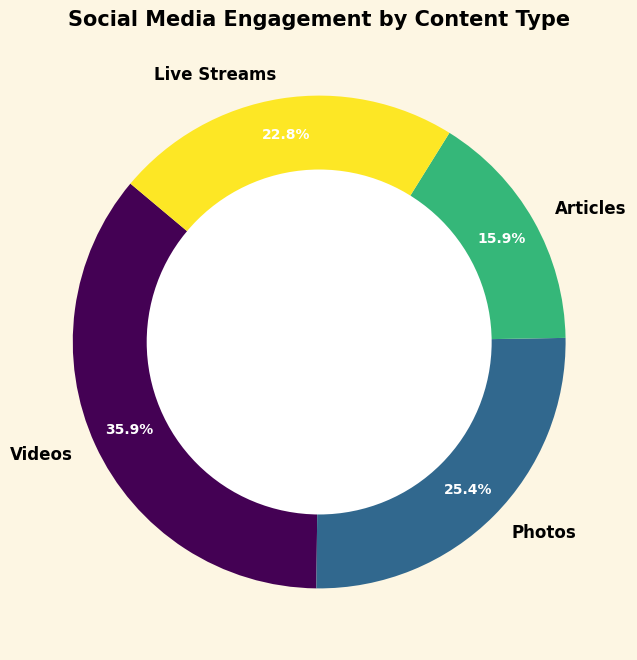What percentage of engagement comes from Videos? By looking at the figure, find the slice labeled "Videos" and locate its percentage label.
Answer: 37.5% Which content type has the least engagement? By observing the sizes of the slices in the ring chart, find the smallest one, which will have the lowest engagement.
Answer: Articles How much more engagement do Videos have compared to Live Streams? From the chart, find the engagement values for Videos and Live Streams (12000 and 7600). Subtract the engagement of Live Streams from Videos (12000 - 7600).
Answer: 4400 What is the combined engagement of Photos and Articles? Identify the engagement values for Photos and Articles (8500 and 5300). Add these values together (8500 + 5300).
Answer: 13800 Which content types collectively contribute to more than half of the total engagement? Calculate the total engagement by summing all types (12000 + 8500 + 5300 + 7600 = 33400). Determine half of this total (33400 / 2 = 16700). By checking the percentages in the chart, Videos (37.5%) and Photos (25.4%) collectively contribute more than half (37.5% + 25.4% = 62.9%).
Answer: Videos and Photos How does the engagement of Live Streams compare to that of Articles visually? Observe the sizes of the slices for Live Streams and Articles. The slice for Live Streams should be noticeably larger than that for Articles.
Answer: Live Streams have more engagement What is the average engagement per content type? Compute the total engagement (12000 + 8500 + 5300 + 7600 = 33400), then divide by the number of content types (33400 / 4).
Answer: 8350 Which content has nearly a quarter of the total engagement? Identify the slice whose percentage is closest to 25%. In this case, the slice for Photos shows 25.4%.
Answer: Photos If you were to combine the engagements of the two least engaging content types, what percentage of the total engagement would they represent? Combine the engagements of Articles (5300) and Live Streams (7600) (5300 + 7600 = 12900). Then calculate what percentage this is of the total (12900 / 33400 * 100).
Answer: 38.6% What's the difference in percentage between the most and least engaging content types? Observe the percentage labels for the most engaging (Videos - 37.5%) and least engaging (Articles - 15.9%) content types in the chart. Subtract the smallest percentage from the largest (37.5% - 15.9%).
Answer: 21.6% 